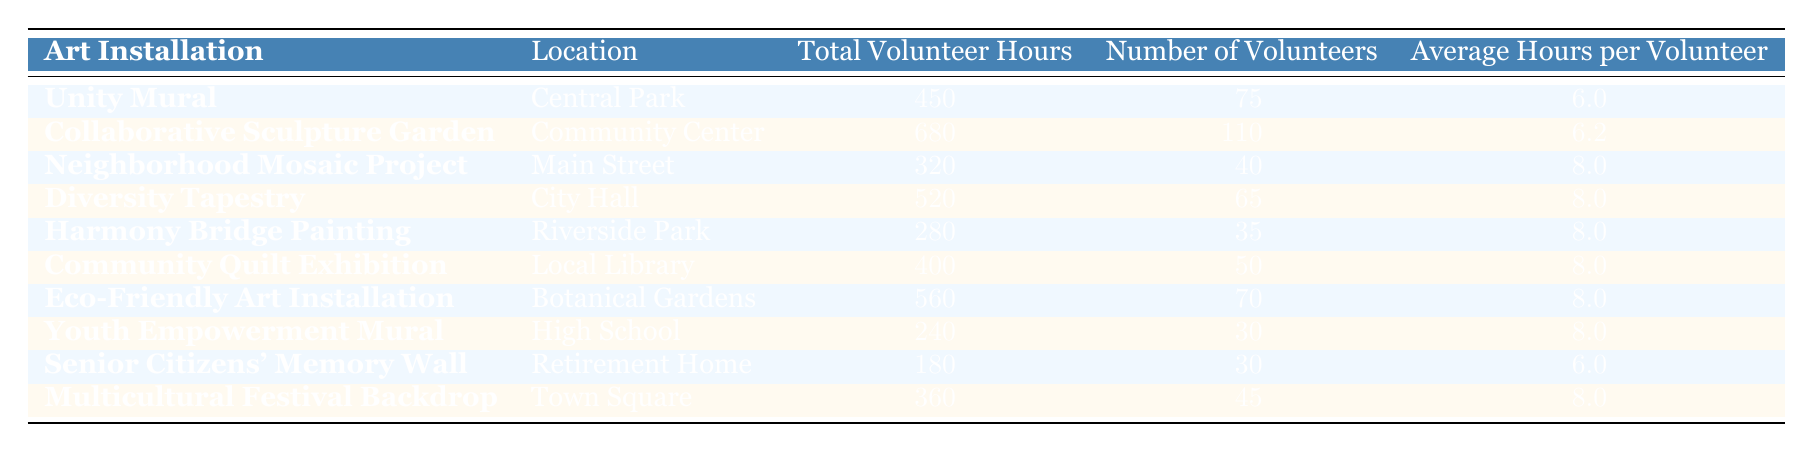What is the total volunteer hours contributed to the "Community Quilt Exhibition"? From the table, I can directly see that the "Community Quilt Exhibition" has a total of 400 volunteer hours listed in the "Total Volunteer Hours" column.
Answer: 400 Which art installation had the highest number of volunteers? The table shows that the "Collaborative Sculpture Garden" has the highest number of volunteers at 110 individuals, which can be directly found in the "Number of Volunteers" column.
Answer: Collaborative Sculpture Garden How many total volunteer hours were contributed to art installations located at parks? The art installations located at parks from the table are "Unity Mural" (450), "Harmony Bridge Painting" (280), and "Eco-Friendly Art Installation" (560). Adding these together: 450 + 280 + 560 = 1290.
Answer: 1290 Is the average hours per volunteer for the "Youth Empowerment Mural" greater than the average for the "Unity Mural"? The average hours per volunteer for the "Youth Empowerment Mural" is 8, while for the "Unity Mural," it is 6. Since 8 is greater than 6, the statement is true.
Answer: Yes What is the difference in total volunteer hours between the "Diversity Tapestry" and the "Senior Citizens' Memory Wall"? The "Diversity Tapestry" contributed 520 total volunteer hours, while the "Senior Citizens' Memory Wall" contributed 180 hours. Subtracting these values: 520 - 180 = 340 gives the difference in total volunteer hours.
Answer: 340 What is the average number of volunteers across all the art installations listed? To find the average, I sum the number of volunteers: 75 + 110 + 40 + 65 + 35 + 50 + 70 + 30 + 30 + 45 =  510. There are 10 installations, so the average is 510 / 10 = 51.
Answer: 51 Do any art installations have an average hours per volunteer below 7? Looking at the table, I see "Unity Mural" (6.0) and "Senior Citizens' Memory Wall" (6.0) have averages below 7, confirming that yes, some installations do.
Answer: Yes Which art installation had the lowest total volunteer hours? The table shows that the "Senior Citizens' Memory Wall" has the lowest total volunteer hours at 180, as seen in the "Total Volunteer Hours" column.
Answer: Senior Citizens' Memory Wall How much more total volunteer hours were contributed to the "Collaborative Sculpture Garden" than the "Youth Empowerment Mural"? The "Collaborative Sculpture Garden" has 680 total volunteer hours, and the "Youth Empowerment Mural" has 240 hours. The difference is 680 - 240 = 440 hours, showing how much more was contributed to the former.
Answer: 440 